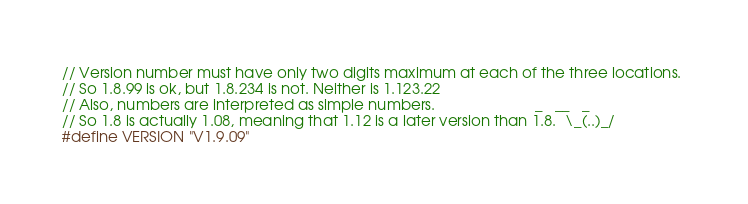Convert code to text. <code><loc_0><loc_0><loc_500><loc_500><_C_>// Version number must have only two digits maximum at each of the three locations. 
// So 1.8.99 is ok, but 1.8.234 is not. Neither is 1.123.22
// Also, numbers are interpreted as simple numbers.                        _   __   _
// So 1.8 is actually 1.08, meaning that 1.12 is a later version than 1.8.  \_(..)_/
#define VERSION "V1.9.09"
</code> 